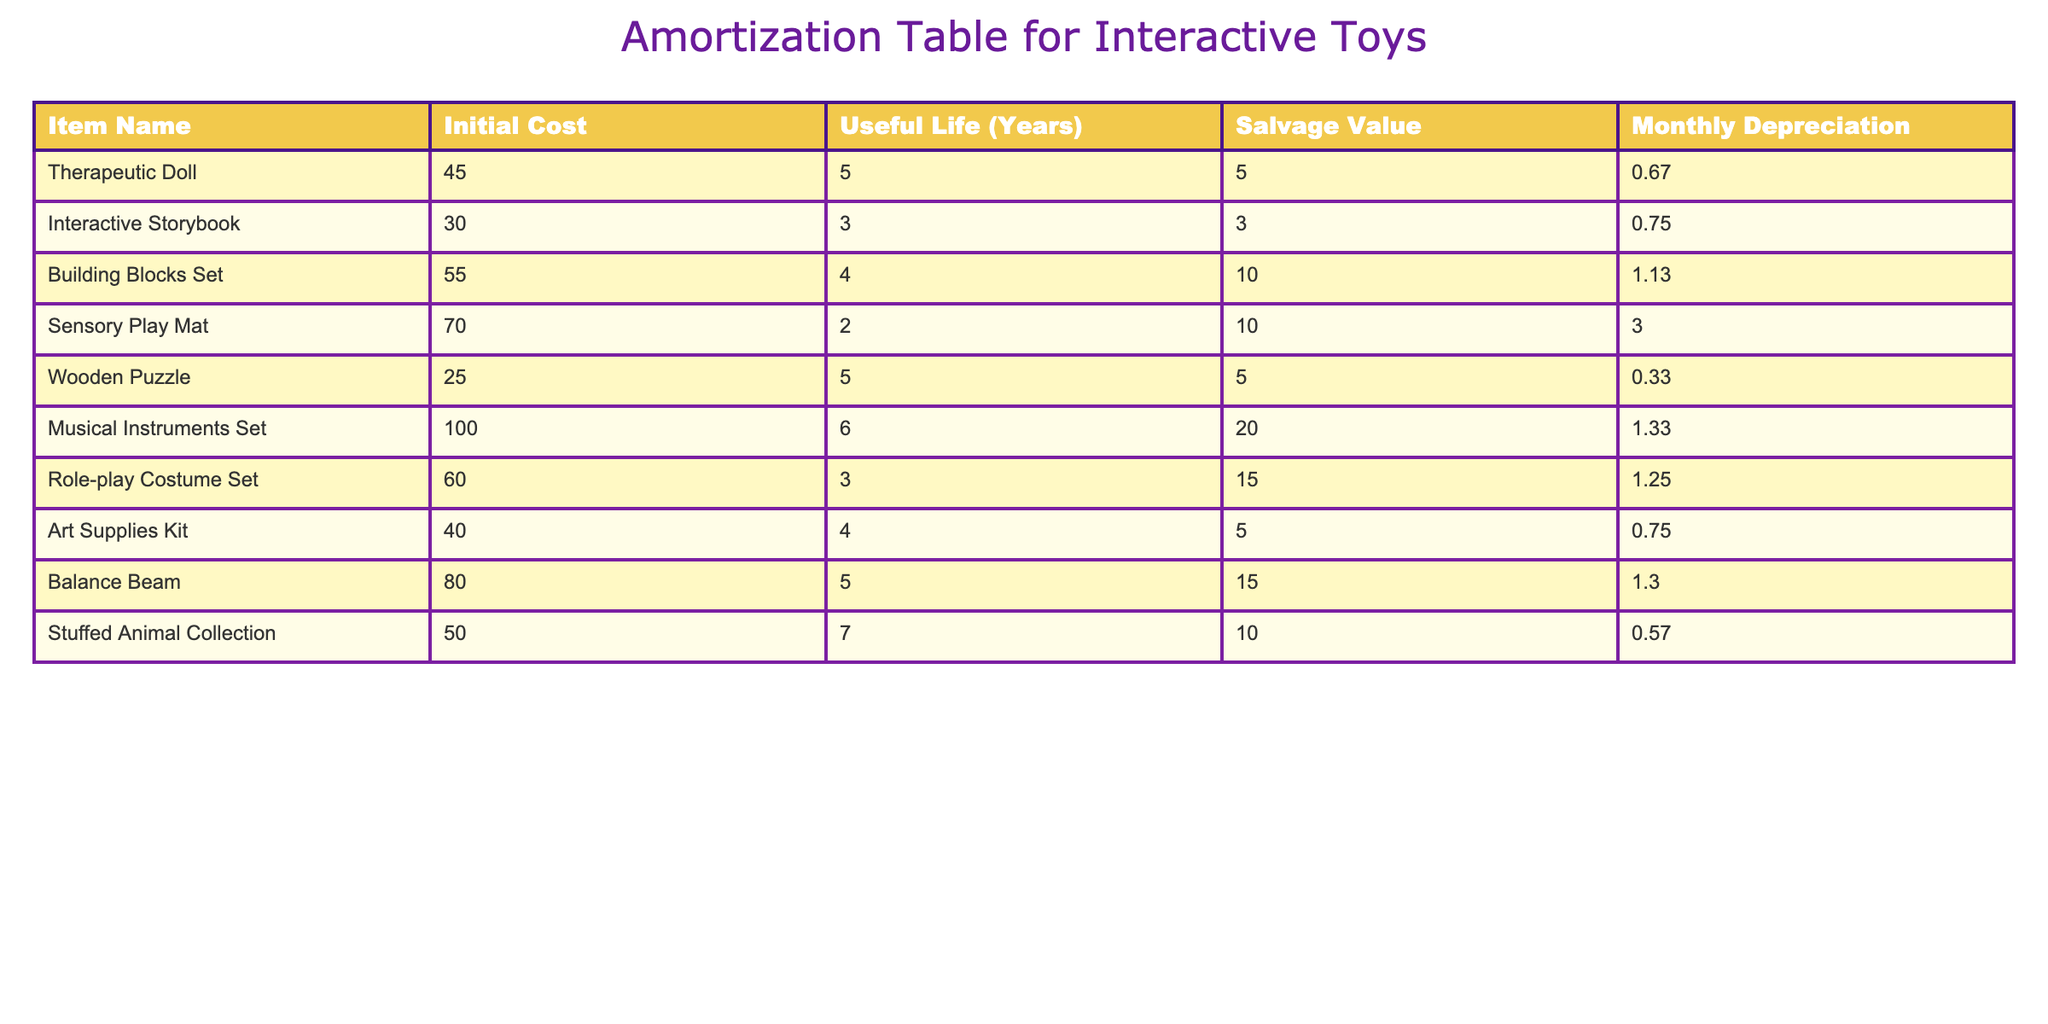What is the initial cost of the Sensory Play Mat? The initial cost is directly provided in the table under the "Initial Cost" column for the Sensory Play Mat row. The value listed is 70.00.
Answer: 70.00 How many years of useful life does the Interactive Storybook have? The useful life of the Interactive Storybook is specified in the "Useful Life (Years)" column of the table. The value listed is 3 years.
Answer: 3 What is the total monthly depreciation for the Therapeutic Doll and the Wooden Puzzle combined? To find the total monthly depreciation, add the monthly depreciation values for both the Therapeutic Doll (0.67) and the Wooden Puzzle (0.33). Thus, 0.67 + 0.33 = 1.00.
Answer: 1.00 Is the salvage value of the Musical Instruments Set greater than the initial cost? Comparing the salvage value (20.00) and initial cost (100.00) of the Musical Instruments Set from the table, the salvage value is less, therefore the answer is no.
Answer: No Which toy has the highest initial cost and what is that cost? By scanning the "Initial Cost" column, the Musical Instruments Set has the highest initial cost at 100.00.
Answer: 100.00 What is the average monthly depreciation of the toys listed in the table? To calculate the average monthly depreciation, sum the monthly depreciation values for all toys: 0.67 + 0.75 + 1.13 + 3.00 + 0.33 + 1.33 + 1.25 + 0.75 + 1.30 + 0.57 = 11.05. Then, divide by the total number of items (10) to get the average: 11.05 / 10 = 1.11.
Answer: 1.11 Do any toys have a salvage value of exactly 10.00? Looking at the "Salvage Value" column, the Building Blocks Set and Stuffed Animal Collection both have a salvage value of 10.00. Therefore, the answer is yes.
Answer: Yes What is the combined initial cost of toys that have a useful life of 5 years? First, identify the toys with a useful life of 5 years from the table: Therapeutic Doll (45.00), Wooden Puzzle (25.00), and Balance Beam (80.00). Adding these gives: 45.00 + 25.00 + 80.00 = 150.00.
Answer: 150.00 Which toy has the lowest monthly depreciation and what is that amount? In the "Monthly Depreciation" column, the Wooden Puzzle has the lowest value at 0.33.
Answer: 0.33 